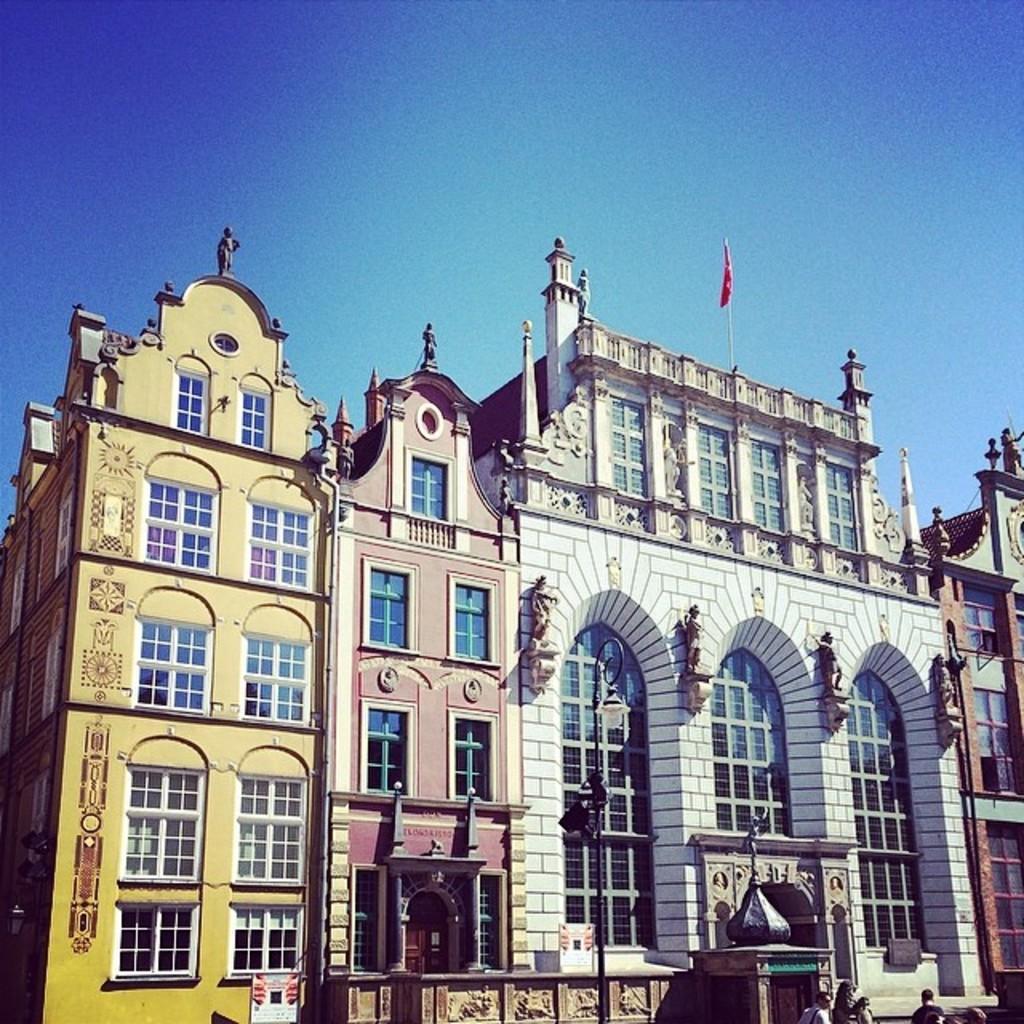Describe this image in one or two sentences. In this image in the middle, there are houses, windows, wall. At the bottom there are some people. At the top there is sky, flag. 